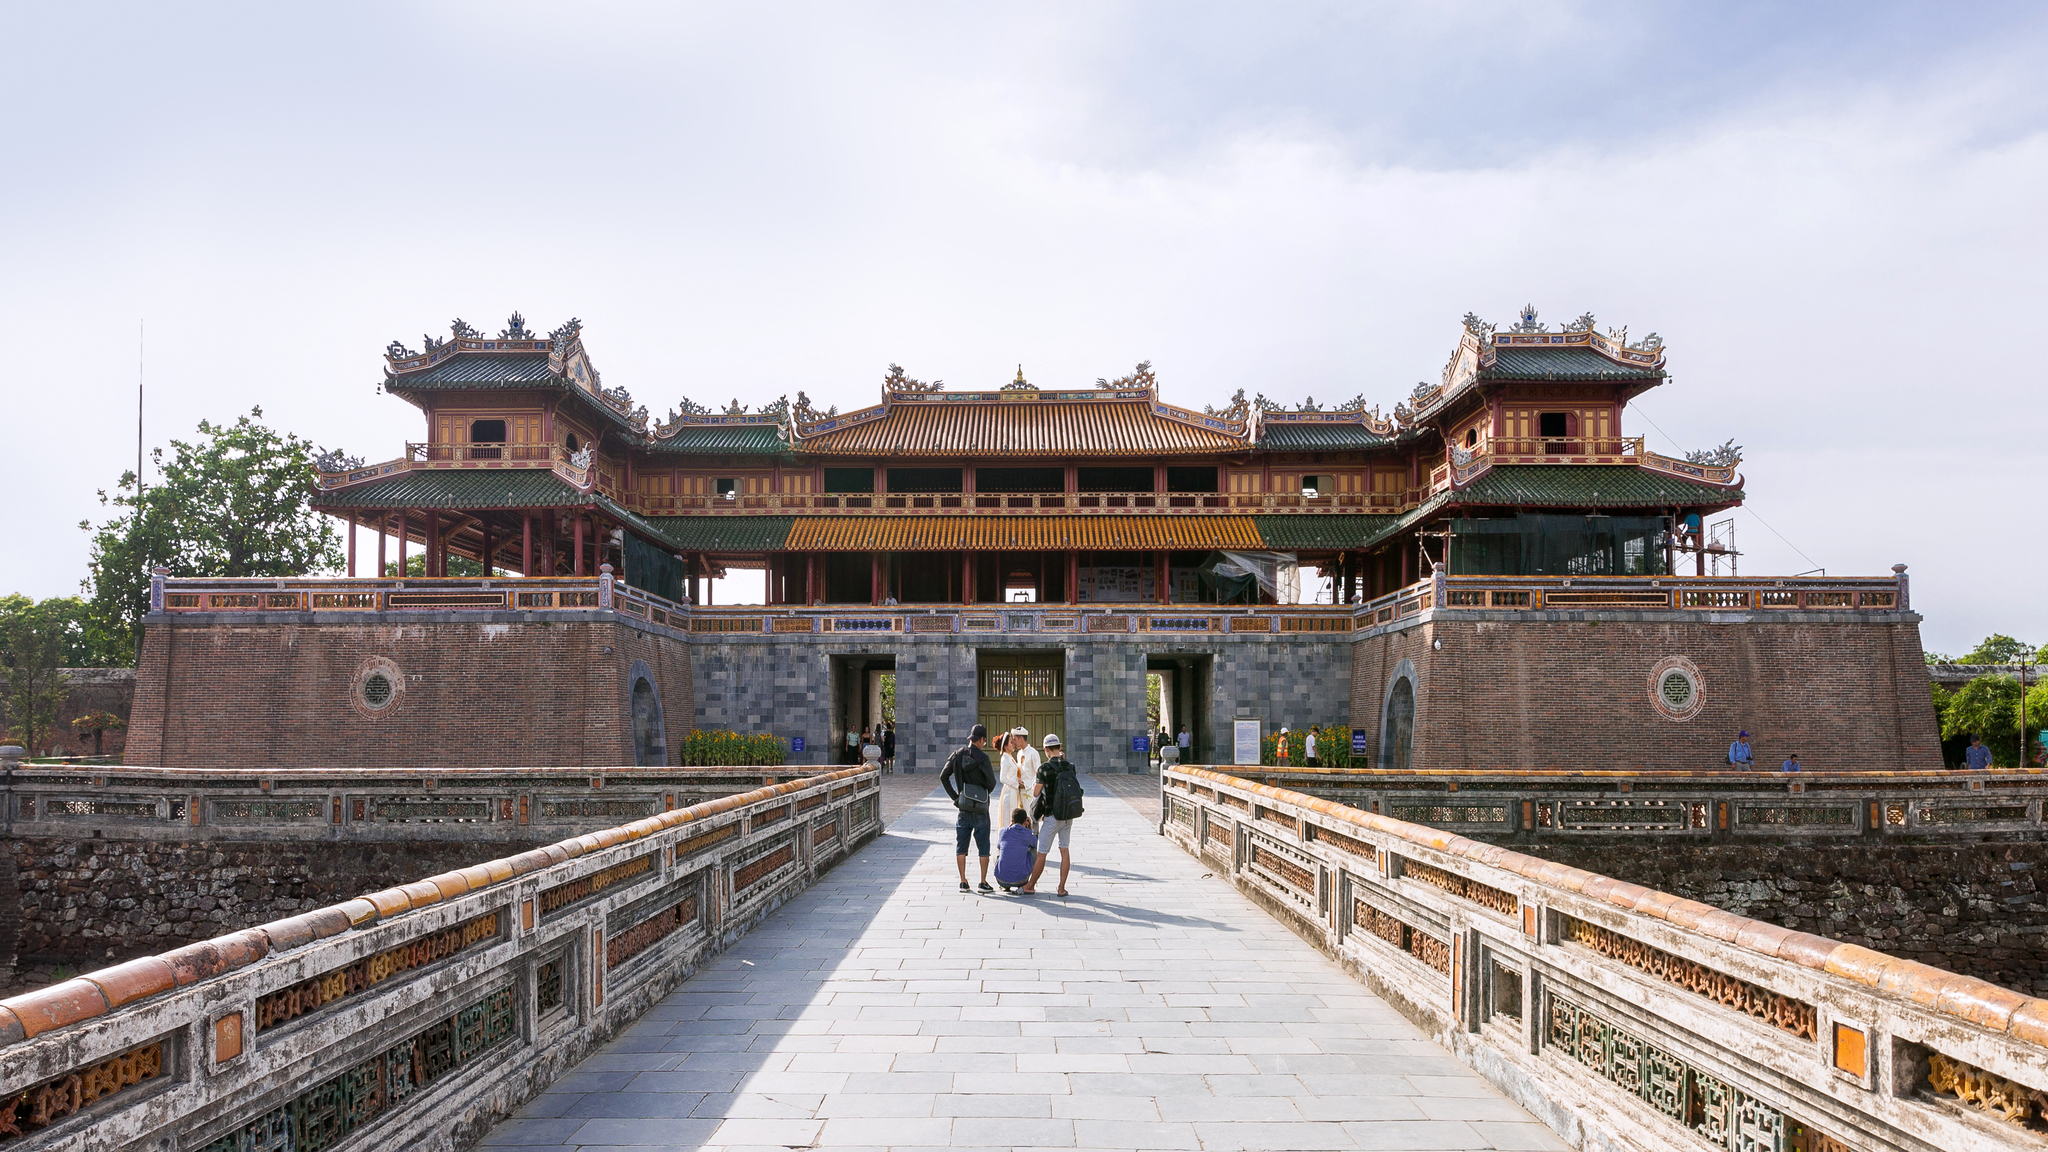Describe the historical significance of this structure. The structure depicted in the image is the Imperial Citadel in Hue, Vietnam, a UNESCO World Heritage Site. This citadel served as the political and cultural center of the Nguyen dynasty, which ruled from 1802 to 1945. Built in the early 19th century, the citadel is a symbol of Vietnamese feudalism and architectural ingenuity, showcasing a blend of traditional Vietnamese design and French military architecture. It housed the emperor, his family, and key administrative offices, making it a crucial hub for the governance and cultural life of Vietnam during this period. What are some unique architectural features of the Imperial Citadel? The Imperial Citadel boasts several unique architectural features that reflect the grandeur and sophistication of Vietnamese design. The complex is surrounded by a moat and high walls, embodying the principles of traditional eastern defensive architecture. Incorporating an extensive use of wood and stone, the structures within the citadel are adorned with intricate carvings and ornamental designs. Notably, the roofs feature intricately designed dragon motifs, a symbol of imperial power. The citadel also includes several gates, pavilions, and halls, each with its own distinct architectural style and purpose, contributing to the overall majestic and harmonious aesthetic of the citadel. Imagine if the citadel was alive, what kind of stories do you think it would tell? If the Imperial Citadel were alive, it would have a rich tapestry of stories to tell. It would recount the bustling daily life within its walls, from grandiose royal ceremonies to the daily routines of officials and servants. The citadel would share tales of intrigue and power struggles, of emperors and their court navigating the complex dynamics of rule. It would speak of the cultural evolution witnessed within its halls, including artistic and literary advancements. The citadel might also relay the trials of warfare and rebellion, enduring sieges and witnessing the turbulence that comes with political change. Above all, it would whisper of a profound legacy, having stood as a silent sentinel through centuries of Vietnam’s history. 